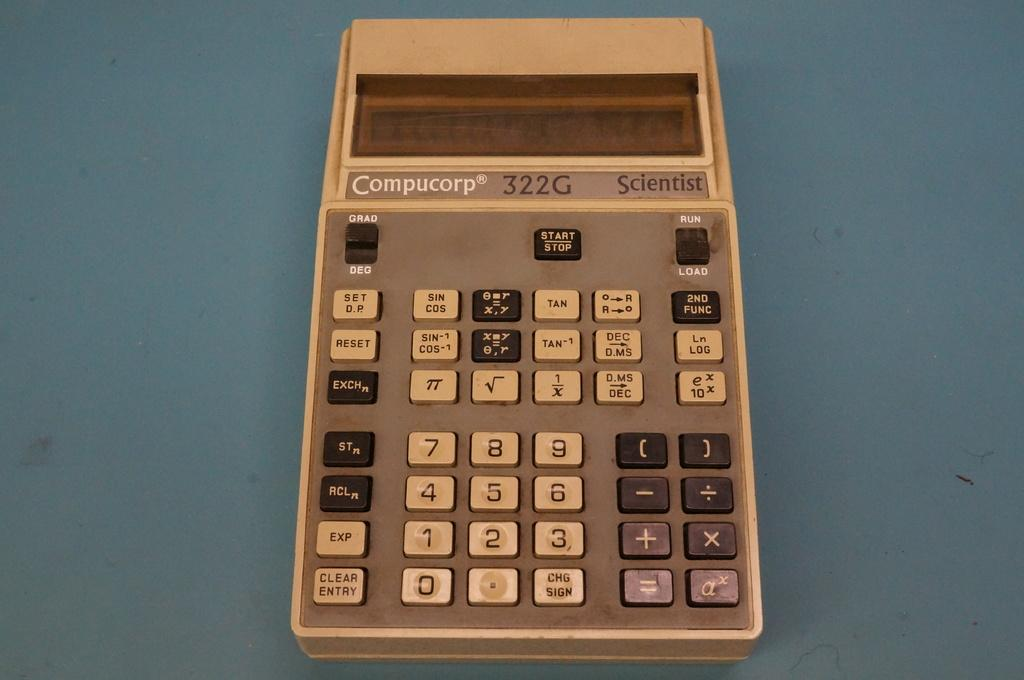<image>
Describe the image concisely. A Compucorp calculator says Scientist on it and is on a blue table. 